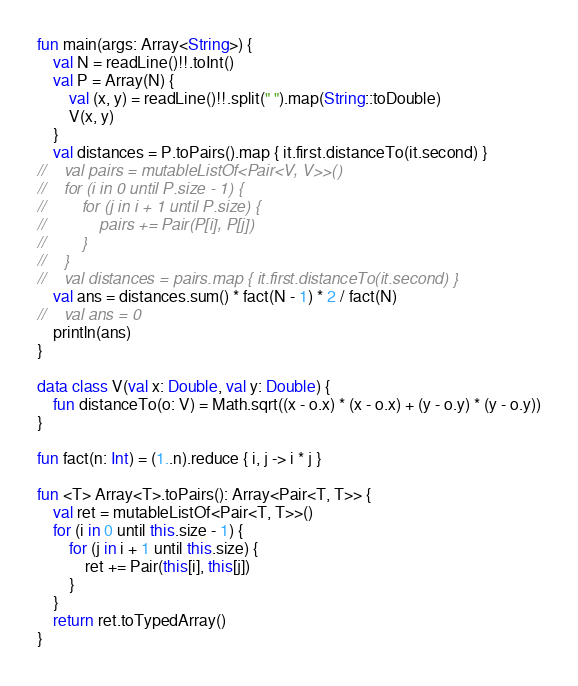Convert code to text. <code><loc_0><loc_0><loc_500><loc_500><_Kotlin_>fun main(args: Array<String>) {
    val N = readLine()!!.toInt()
    val P = Array(N) {
        val (x, y) = readLine()!!.split(" ").map(String::toDouble)
        V(x, y)
    }
    val distances = P.toPairs().map { it.first.distanceTo(it.second) }
//    val pairs = mutableListOf<Pair<V, V>>()
//    for (i in 0 until P.size - 1) {
//        for (j in i + 1 until P.size) {
//            pairs += Pair(P[i], P[j])
//        }
//    }
//    val distances = pairs.map { it.first.distanceTo(it.second) }
    val ans = distances.sum() * fact(N - 1) * 2 / fact(N)
//    val ans = 0
    println(ans)
}

data class V(val x: Double, val y: Double) {
    fun distanceTo(o: V) = Math.sqrt((x - o.x) * (x - o.x) + (y - o.y) * (y - o.y))
}

fun fact(n: Int) = (1..n).reduce { i, j -> i * j }

fun <T> Array<T>.toPairs(): Array<Pair<T, T>> {
    val ret = mutableListOf<Pair<T, T>>()
    for (i in 0 until this.size - 1) {
        for (j in i + 1 until this.size) {
            ret += Pair(this[i], this[j])
        }
    }
    return ret.toTypedArray()
}</code> 